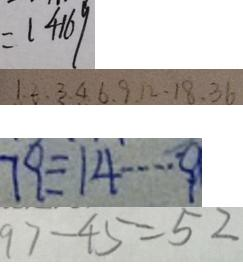Convert formula to latex. <formula><loc_0><loc_0><loc_500><loc_500>= 1 4 1 6 9 
 1 . 2 . 3 . 4 . 6 . 9 . 1 2 . 1 8 . 3 6 
 7 9 \div 1 4 \cdots 9 
 9 7 - 4 5 = 5 2</formula> 